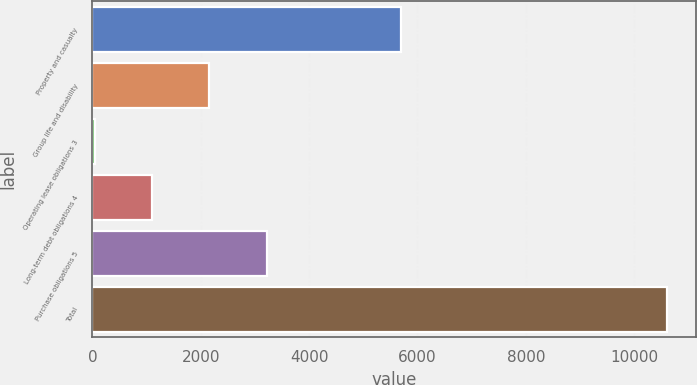<chart> <loc_0><loc_0><loc_500><loc_500><bar_chart><fcel>Property and casualty<fcel>Group life and disability<fcel>Operating lease obligations 3<fcel>Long-term debt obligations 4<fcel>Purchase obligations 5<fcel>Total<nl><fcel>5705<fcel>2158.4<fcel>45<fcel>1101.7<fcel>3215.1<fcel>10612<nl></chart> 